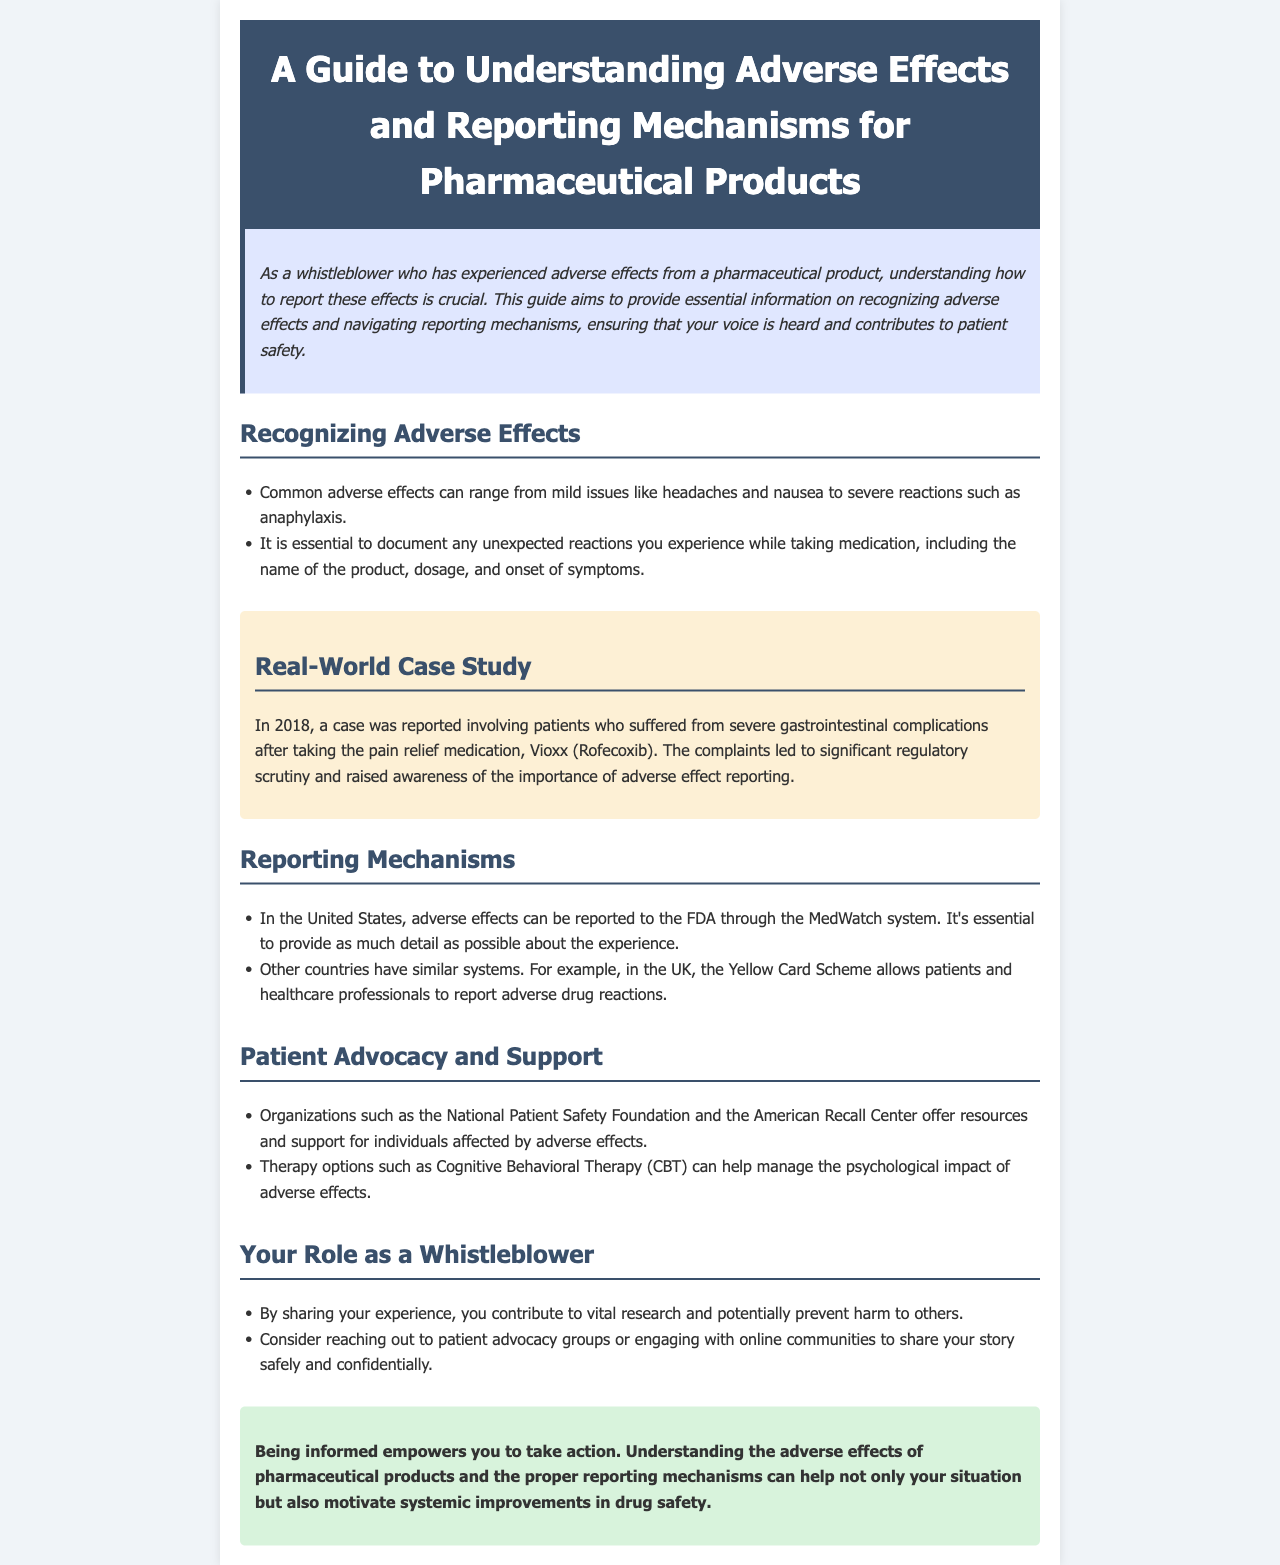what is the title of the document? The title is prominently displayed at the top of the document.
Answer: A Guide to Understanding Adverse Effects and Reporting Mechanisms for Pharmaceutical Products what is the MedWatch system? The MedWatch system is a mechanism for reporting adverse effects in the United States, mentioned in the reporting mechanisms section.
Answer: A reporting system who experienced gastrointestinal complications in 2018? The case study refers to patients who suffered from complications after taking a specific medication.
Answer: Patients what is a common mild adverse effect mentioned? The document lists common adverse effects, including their severity levels.
Answer: Headaches what are organizations that offer resources for those affected by adverse effects? This information is found in the Patient Advocacy and Support section of the document.
Answer: National Patient Safety Foundation, American Recall Center what therapeutic option is suggested for managing psychological impact? The document provides a recommendation for therapy options that help manage psychological effects.
Answer: Cognitive Behavioral Therapy (CBT) how can sharing experiences help others? The document emphasizes the role of whistleblowers in contributing to research and safety improvements.
Answer: Prevent harm in which country is the Yellow Card Scheme used? This information is specified under the Reporting Mechanisms section in the document.
Answer: United Kingdom 